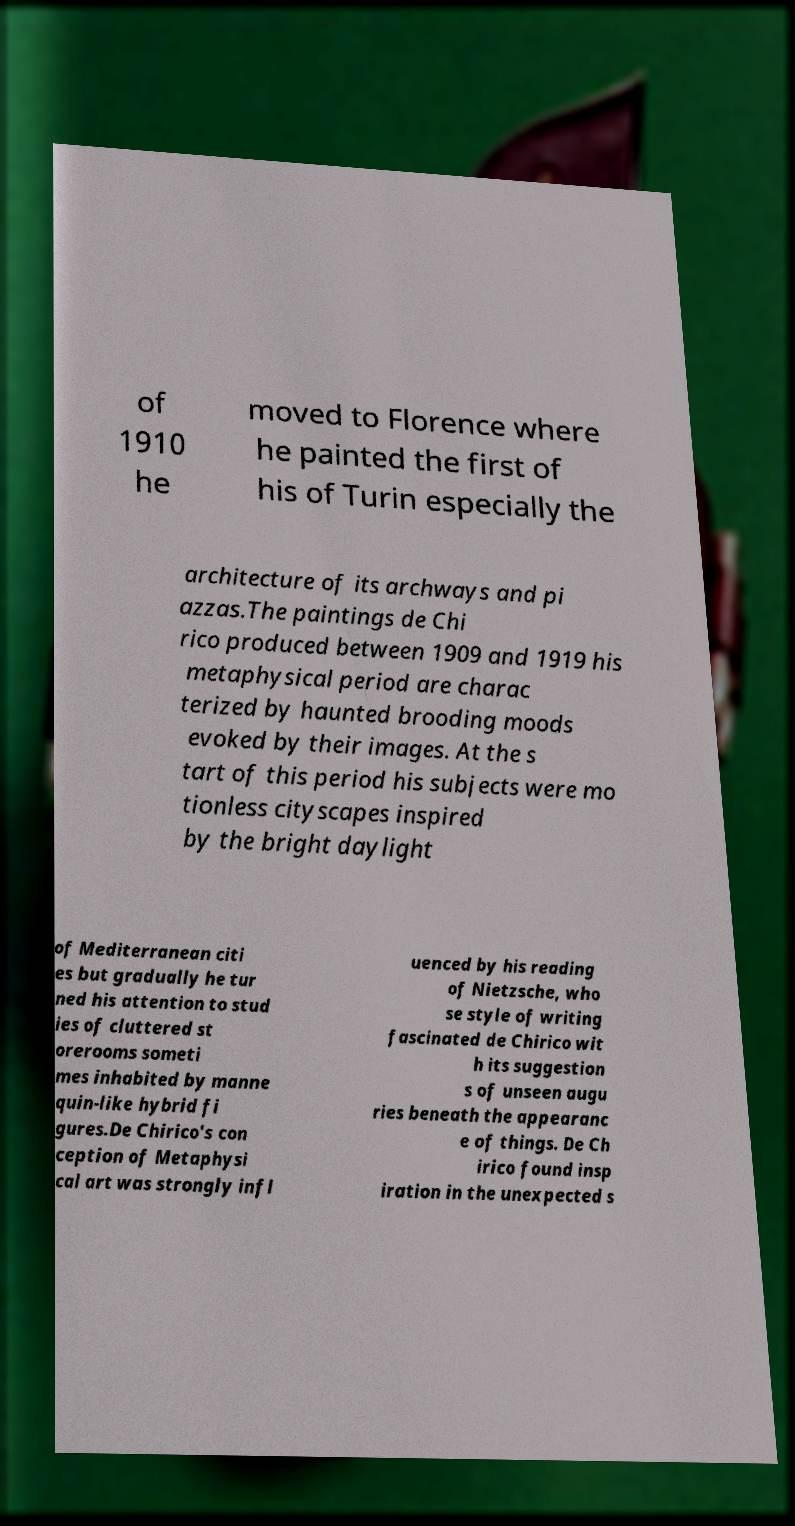There's text embedded in this image that I need extracted. Can you transcribe it verbatim? of 1910 he moved to Florence where he painted the first of his of Turin especially the architecture of its archways and pi azzas.The paintings de Chi rico produced between 1909 and 1919 his metaphysical period are charac terized by haunted brooding moods evoked by their images. At the s tart of this period his subjects were mo tionless cityscapes inspired by the bright daylight of Mediterranean citi es but gradually he tur ned his attention to stud ies of cluttered st orerooms someti mes inhabited by manne quin-like hybrid fi gures.De Chirico's con ception of Metaphysi cal art was strongly infl uenced by his reading of Nietzsche, who se style of writing fascinated de Chirico wit h its suggestion s of unseen augu ries beneath the appearanc e of things. De Ch irico found insp iration in the unexpected s 